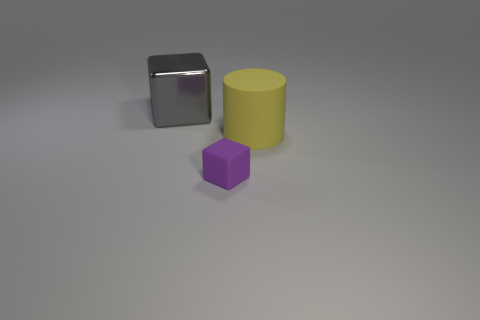There is a cube behind the big rubber cylinder; is there a big yellow rubber object in front of it?
Give a very brief answer. Yes. How many big matte things are to the left of the rubber block?
Offer a terse response. 0. The large object that is the same shape as the tiny rubber thing is what color?
Ensure brevity in your answer.  Gray. Is the material of the gray cube behind the small purple matte thing the same as the big thing to the right of the small rubber cube?
Ensure brevity in your answer.  No. The thing that is both behind the tiny thing and in front of the gray metal block has what shape?
Offer a very short reply. Cylinder. What number of small brown metal blocks are there?
Your response must be concise. 0. There is another purple thing that is the same shape as the large metallic thing; what is its size?
Keep it short and to the point. Small. There is a object to the right of the purple object; is it the same shape as the purple rubber object?
Make the answer very short. No. The block left of the tiny purple matte cube is what color?
Keep it short and to the point. Gray. What number of other objects are the same size as the gray shiny object?
Your answer should be very brief. 1. 